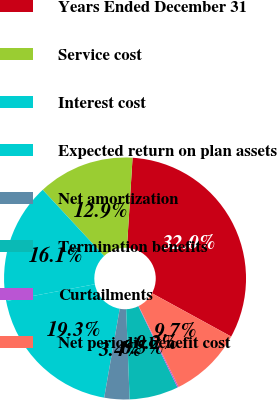Convert chart. <chart><loc_0><loc_0><loc_500><loc_500><pie_chart><fcel>Years Ended December 31<fcel>Service cost<fcel>Interest cost<fcel>Expected return on plan assets<fcel>Net amortization<fcel>Termination benefits<fcel>Curtailments<fcel>Net periodic benefit cost<nl><fcel>31.98%<fcel>12.9%<fcel>16.08%<fcel>19.26%<fcel>3.36%<fcel>6.54%<fcel>0.17%<fcel>9.72%<nl></chart> 